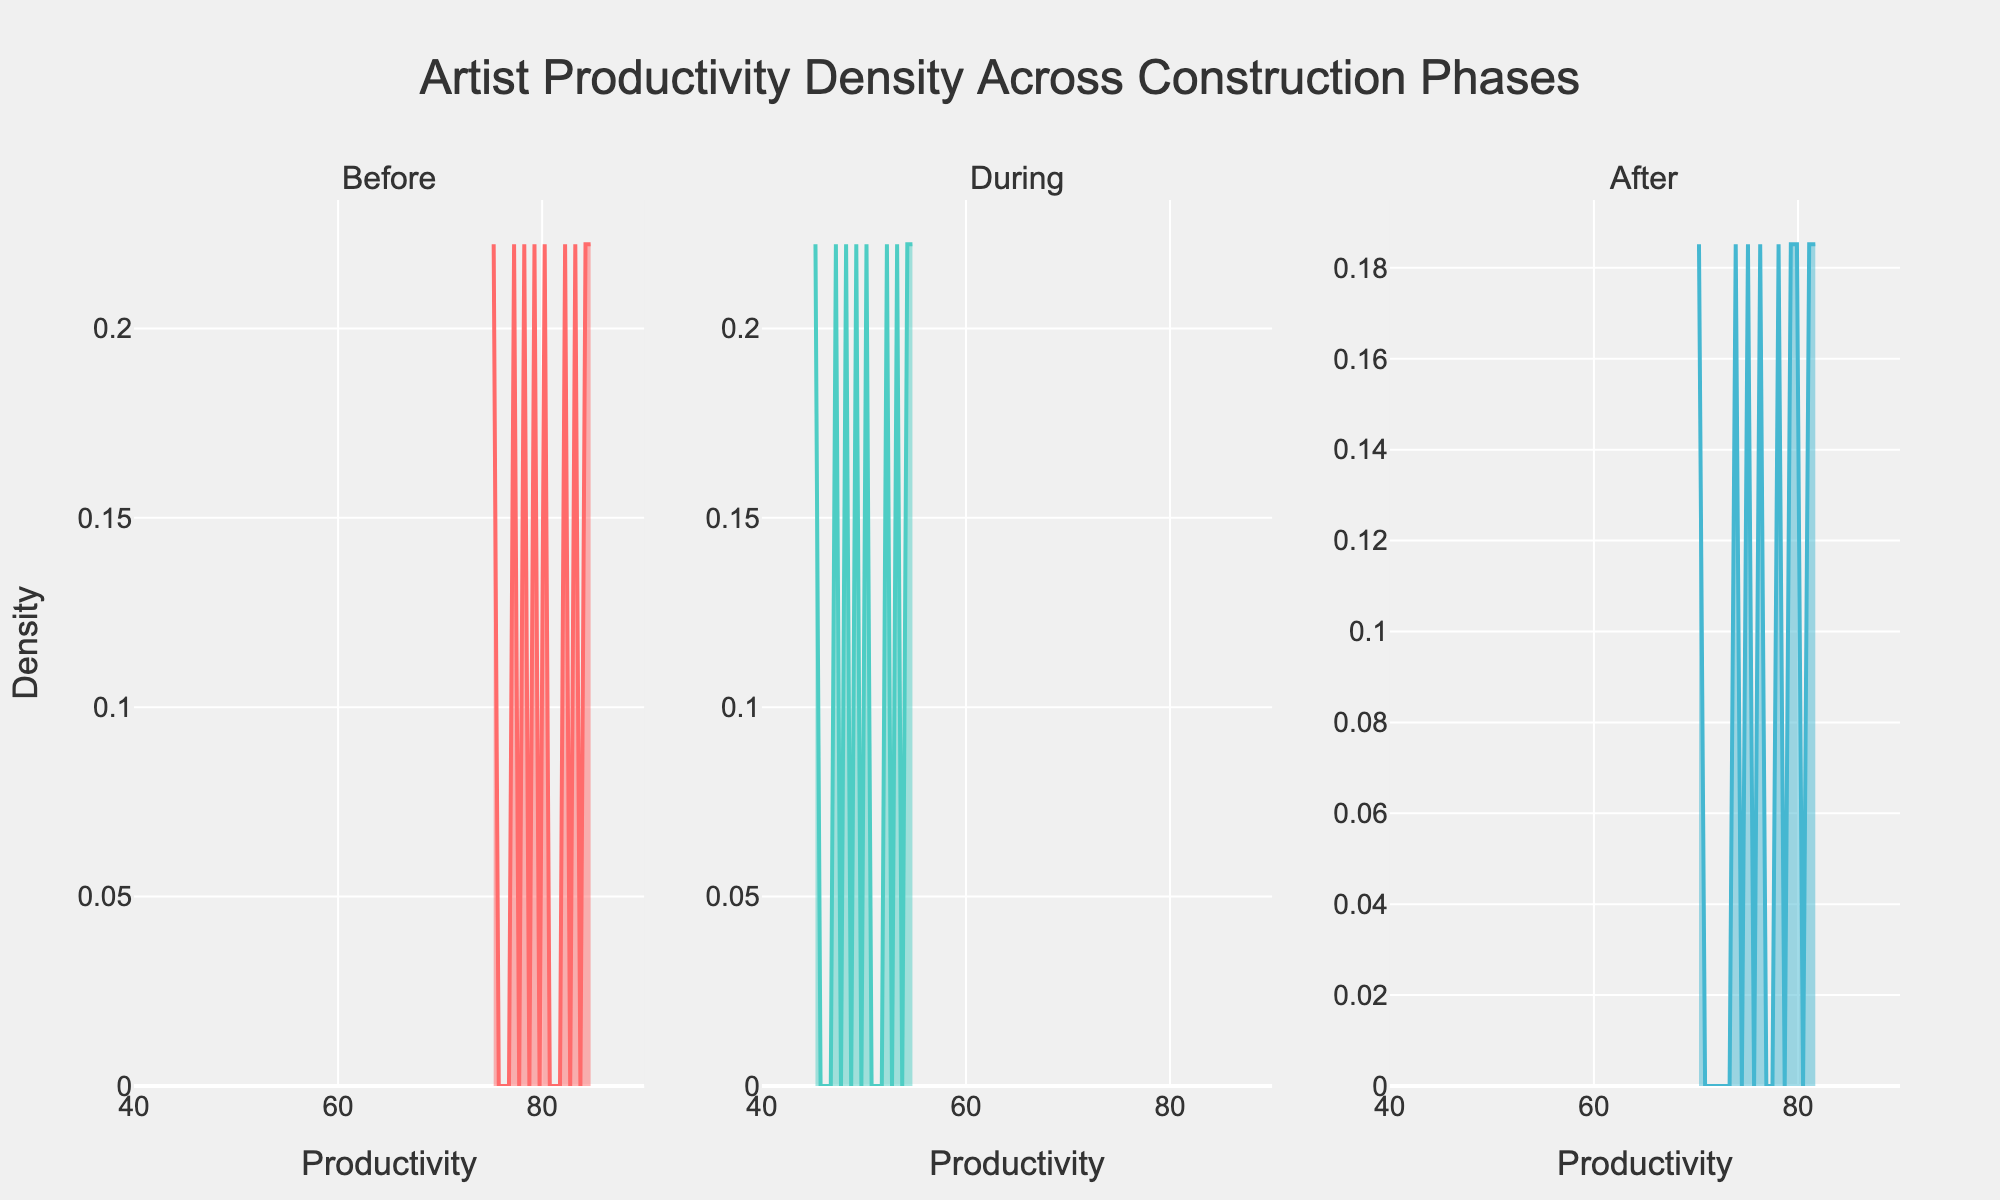What does the title of the figure say? The title text is located at the top center of the figure and reads "Artist Productivity Density Across Construction Phases"
Answer: Artist Productivity Density Across Construction Phases What are the phases represented in the subplots? The subplot titles are located above each of the three subplots and indicate the phases "Before," "During," and "After" the construction.
Answer: Before, During, After What is the range of productivity values on the x-axis? Each subplot x-axis is labeled "Productivity" and has a range marked from 40 to 90 units.
Answer: 40 to 90 How does the color change across the different phases? The density plots for each phase are represented with different colors. The "Before" phase is represented in red, the "During" phase in teal, and the "After" phase in blue.
Answer: Before: Red, During: Teal, After: Blue Which phase shows the lowest density peak in productivity? The density peaks can be visually assessed for each phase's subplot. The "During" phase has the lowest density peak compared to "Before" and "After" phases.
Answer: During Which phase shows the highest average productivity level? Visually comparing the density plots, the area under the density curve indicates central tendency. The "Before" phase's curve appears centered around a higher productivity value compared to "During" and "After."
Answer: Before How does the productivity distribution change from the "Before" phase to the "During"? Comparing the "Before" and "During" phase subplots, the "During" phase curve shifts leftward (lower productivity) and flattens (lower density), indicating a decrease in productivity levels and higher variation.
Answer: Decreases and more spread out What can you infer about the artists' productivity after the construction ended, based on this plot? The "After" phase density plot shows a central productivity level close to the "Before" phase but slightly lower, suggesting a partial recovery in productivity after construction disturbances.
Answer: Partially recovered but slightly lower Which phase is likely to have the highest variability in productivity? The subplot for the "During" phase has a flattened and widened density curve, suggesting that artist productivity was more variable during construction.
Answer: During 